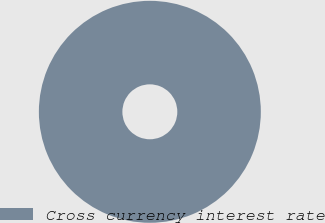Convert chart to OTSL. <chart><loc_0><loc_0><loc_500><loc_500><pie_chart><fcel>Cross currency interest rate<nl><fcel>100.0%<nl></chart> 